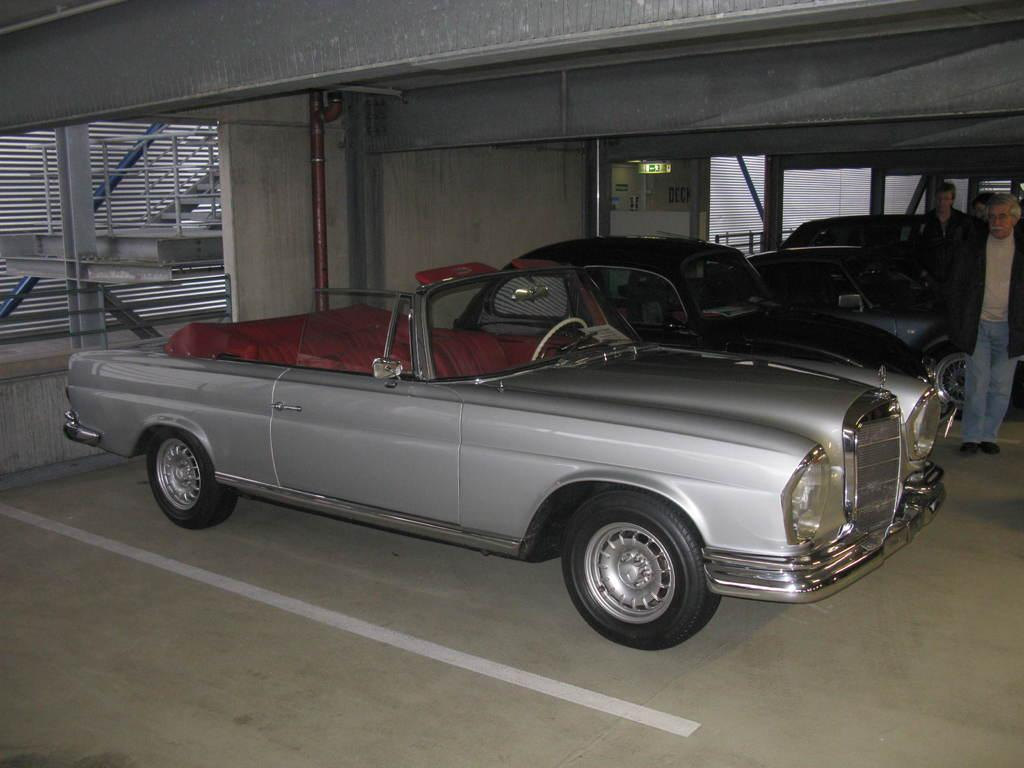What type of vehicles can be seen in the image? There are cars in the image. Who or what else is present in the image? There are people in the image. What can be seen on the ground in the image? There is a path visible in the image. What is in the background of the image? There is a wall in the background of the image. What is located at the top left corner of the image? There are bars on the left top of the image. Can you tell me where the toad's friend is sitting in the image? There is no toad or friend present in the image. What is the mom doing in the image? There is no mom present in the image. 